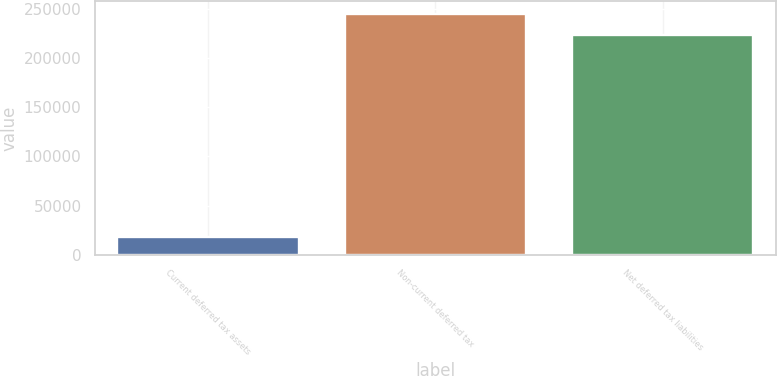<chart> <loc_0><loc_0><loc_500><loc_500><bar_chart><fcel>Current deferred tax assets<fcel>Non-current deferred tax<fcel>Net deferred tax liabilities<nl><fcel>17915<fcel>245071<fcel>222792<nl></chart> 